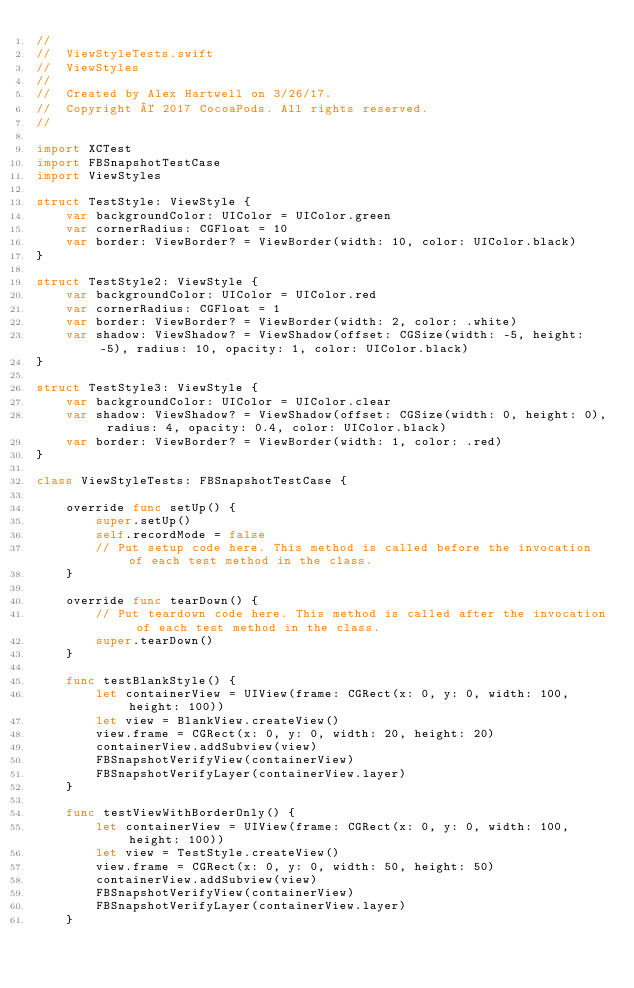<code> <loc_0><loc_0><loc_500><loc_500><_Swift_>//
//  ViewStyleTests.swift
//  ViewStyles
//
//  Created by Alex Hartwell on 3/26/17.
//  Copyright © 2017 CocoaPods. All rights reserved.
//

import XCTest
import FBSnapshotTestCase
import ViewStyles

struct TestStyle: ViewStyle {
    var backgroundColor: UIColor = UIColor.green
    var cornerRadius: CGFloat = 10
    var border: ViewBorder? = ViewBorder(width: 10, color: UIColor.black)
}

struct TestStyle2: ViewStyle {
    var backgroundColor: UIColor = UIColor.red
    var cornerRadius: CGFloat = 1
    var border: ViewBorder? = ViewBorder(width: 2, color: .white)
    var shadow: ViewShadow? = ViewShadow(offset: CGSize(width: -5, height: -5), radius: 10, opacity: 1, color: UIColor.black)
}

struct TestStyle3: ViewStyle {
    var backgroundColor: UIColor = UIColor.clear
    var shadow: ViewShadow? = ViewShadow(offset: CGSize(width: 0, height: 0), radius: 4, opacity: 0.4, color: UIColor.black)
    var border: ViewBorder? = ViewBorder(width: 1, color: .red)
}

class ViewStyleTests: FBSnapshotTestCase {
    
    override func setUp() {
        super.setUp()
        self.recordMode = false
        // Put setup code here. This method is called before the invocation of each test method in the class.
    }
    
    override func tearDown() {
        // Put teardown code here. This method is called after the invocation of each test method in the class.
        super.tearDown()
    }
    
    func testBlankStyle() {
        let containerView = UIView(frame: CGRect(x: 0, y: 0, width: 100, height: 100))
        let view = BlankView.createView()
        view.frame = CGRect(x: 0, y: 0, width: 20, height: 20)
        containerView.addSubview(view)
        FBSnapshotVerifyView(containerView)
        FBSnapshotVerifyLayer(containerView.layer)
    }
    
    func testViewWithBorderOnly() {
        let containerView = UIView(frame: CGRect(x: 0, y: 0, width: 100, height: 100))
        let view = TestStyle.createView()
        view.frame = CGRect(x: 0, y: 0, width: 50, height: 50)
        containerView.addSubview(view)
        FBSnapshotVerifyView(containerView)
        FBSnapshotVerifyLayer(containerView.layer)
    }
    </code> 